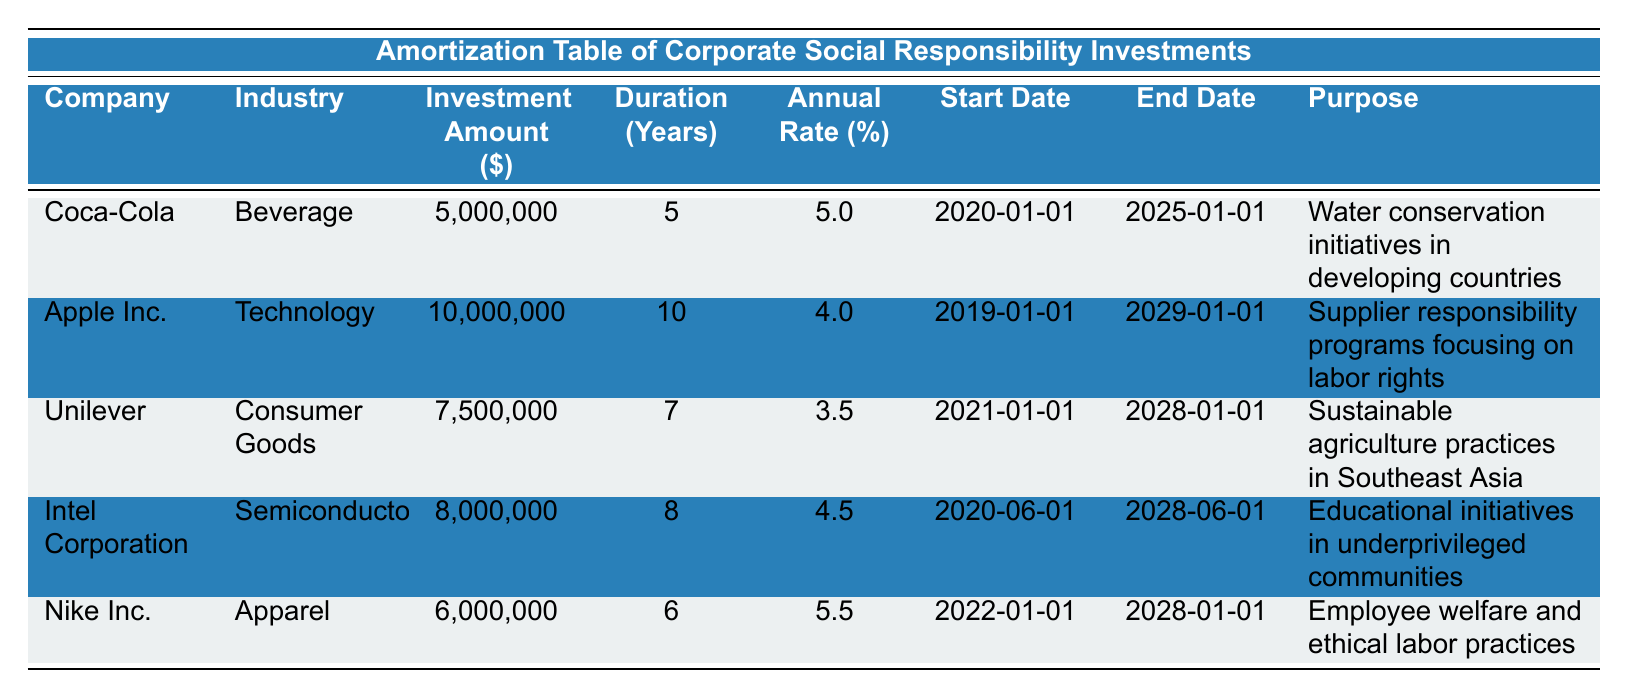What is the investment amount made by Coca-Cola? The investment amount for Coca-Cola is explicitly listed in the table under the “Investment Amount” column, which shows 5,000,000.
Answer: 5,000,000 Which company has the highest investment amount? By comparing the investment amounts in the table, Apple Inc. has the highest amount at 10,000,000, while others are lower.
Answer: Apple Inc What is the average duration of the investments? The durations are 5, 10, 7, 8, and 6 years. Summing these gives 5 + 10 + 7 + 8 + 6 = 36 years. There are 5 companies, so the average is 36/5 = 7.2 years.
Answer: 7.2 years Is the purpose of Unilever’s investment focused on water conservation? The purpose of Unilever's investment is given as "Sustainable agriculture practices in Southeast Asia," which is not centered on water conservation. Hence, the statement is false.
Answer: No Which industry has the shortest duration of investment among the listed companies? By checking the duration column, Coca-Cola has the shortest duration of 5 years compared to the other companies.
Answer: Beverage What is the total amount invested across all companies? The total investments add up to 5,000,000 + 10,000,000 + 7,500,000 + 8,000,000 + 6,000,000 = 36,500,000.
Answer: 36,500,000 Does Nike Inc.’s investment purpose include ethical labor practices? The purpose for Nike Inc. is explicitly stated as "Employee welfare and ethical labor practices," indicating that it does include ethical practices. Therefore, the statement is true.
Answer: Yes Which company has the lowest annual rate of investment? Comparing the annual rates, Unilever's rate is the lowest at 3.5%, while all others have higher rates.
Answer: Unilever What is the longest duration of investment and which company has it? The longest duration is 10 years, which belongs to Apple Inc. as indicated in the duration column of the table.
Answer: Apple Inc 